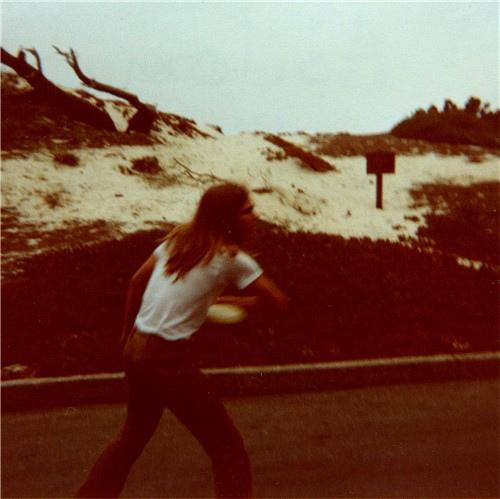Would you see this scene if you were at a zoo?
Short answer required. No. Is there a sign in the scene?
Answer briefly. Yes. What is the man preparing to do?
Quick response, please. Throw frisbee. How long is the man's hair?
Write a very short answer. Past shoulders. 